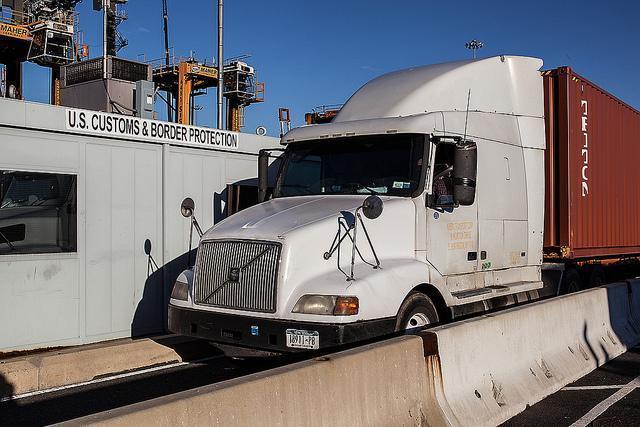How many people are on the boat?
Give a very brief answer. 0. 